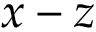Convert formula to latex. <formula><loc_0><loc_0><loc_500><loc_500>x - z</formula> 